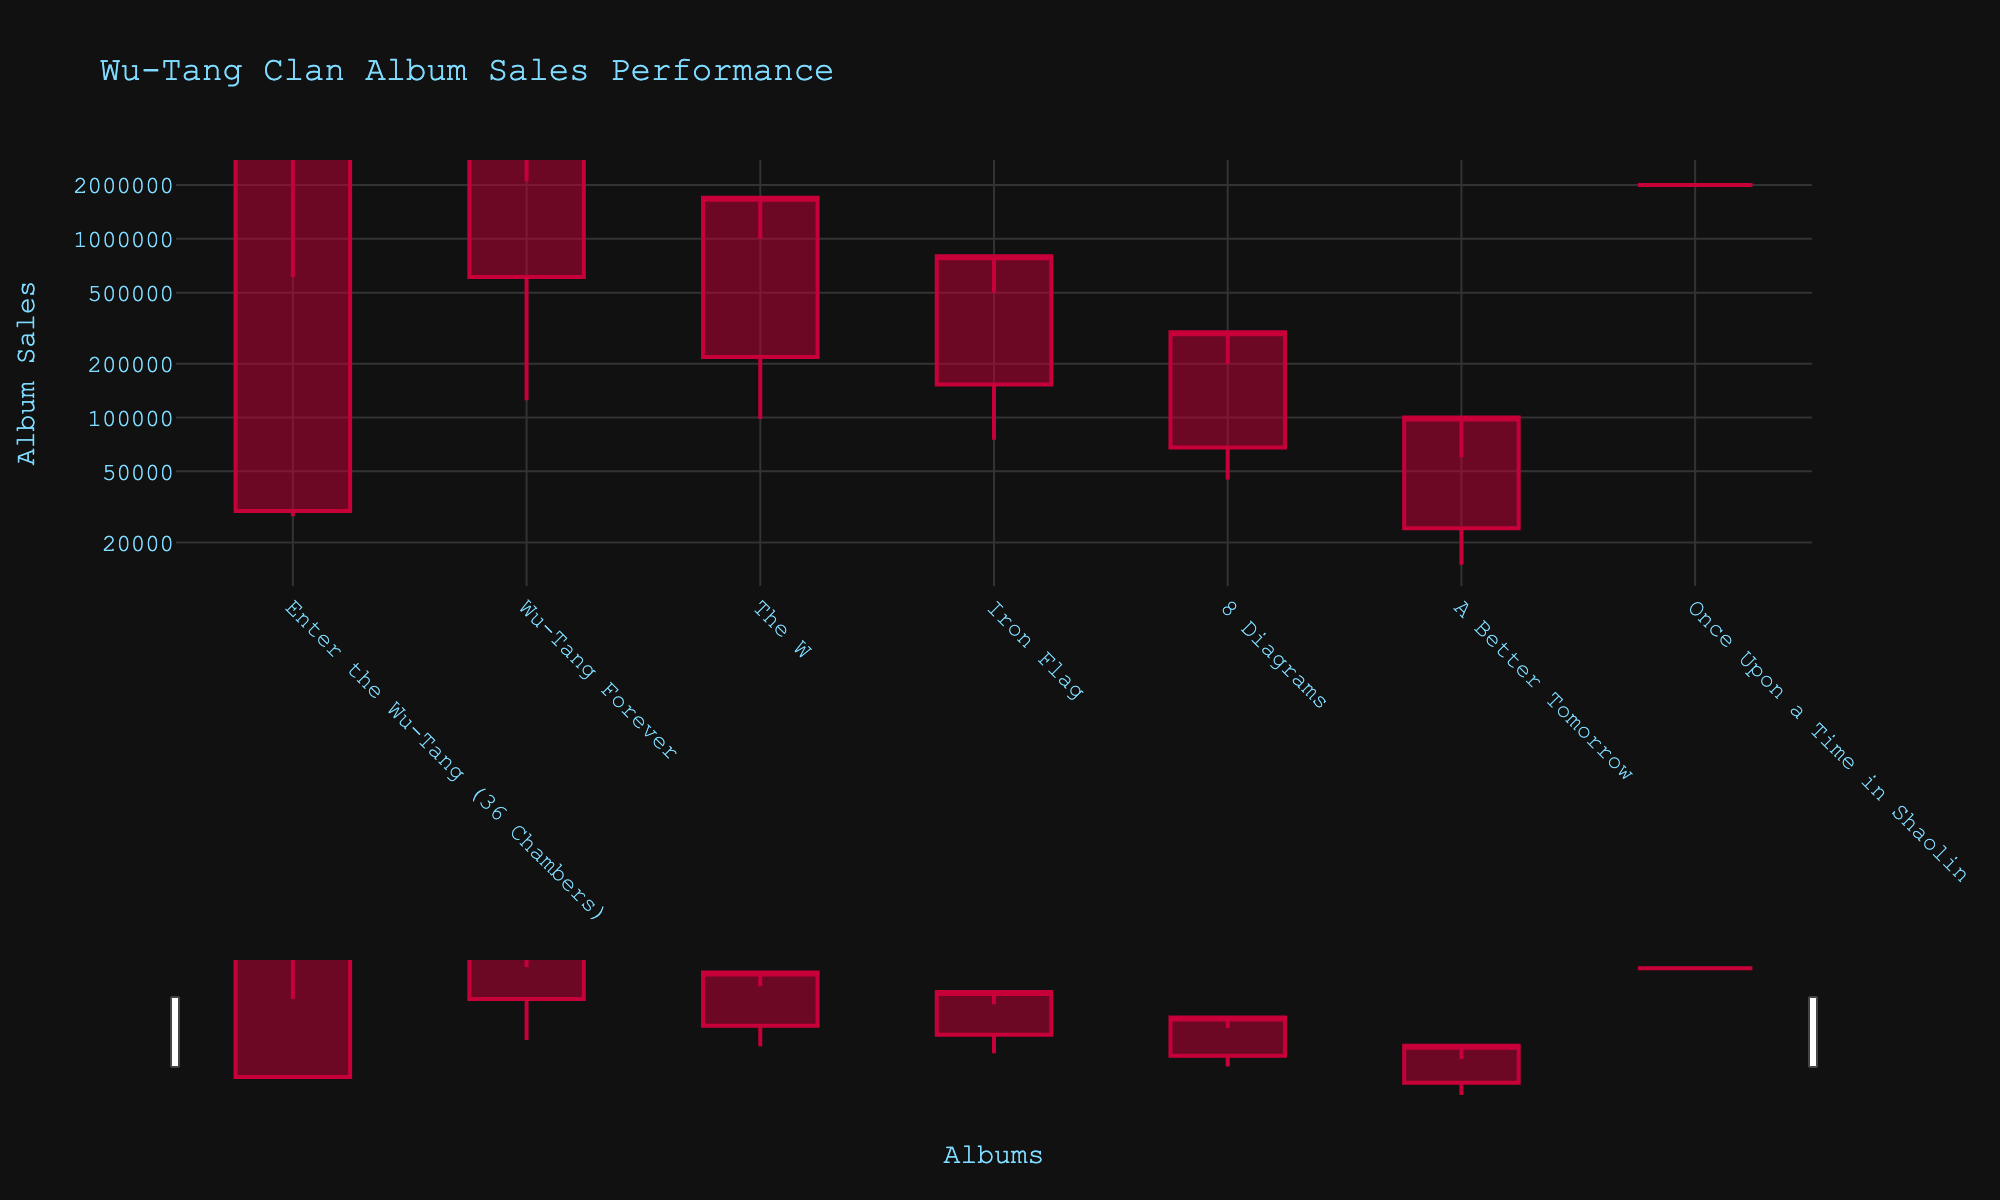what is the title of the chart? The title is typically displayed at the top center of the figure and shows the purpose of the plot. In this chart, the title is "Wu-Tang Clan Album Sales Performance".
Answer: Wu-Tang Clan Album Sales Performance how many initial album sales are displayed in the chart? Count the number of individual bars (or data points) in the figure to determine how many initial album sales are represented. Each bar corresponds to one album's sales performance.
Answer: 7 Which album had the highest opening week sales? Look at the opening week values for each album and identify the one with the largest value. The opening week sales are represented by the bottom of the colored bar when it starts.
Answer: Wu-Tang Forever What is the lowest recorded sales peak among all the albums? Identify and compare the highest peak values for each album and find the smallest one by observing the top of the bars.
Answer: 60,000 (A Better Tomorrow) which album shows the least difference between its highest peak and lowest dip? Subtract the lowest dip from the highest peak for each album, then identify the album with the smallest difference. "Once Upon a Time in Shaolin" has the same value for highest peak and lowest dip resulting in the smallest difference (0).
Answer: Once Upon a Time in Shaolin Which album had sales performance close to 1 million at its peak? Look for the album whose highest peak value is nearest to 1 million. The highest peak is represented by the highest point of the bars.
Answer: The W What is the average opening week sales for all albums? To calculate the average, sum the opening week sales of all the albums and then divide the total by the number of albums. The opening week sales figures to sum are 30,000, 612,000, 218,000, 153,000, 68,000, 24,000, and 2,000,000. Adding these gives 3,105,000, and dividing by 7 gives the average.
Answer: 443,571 Which album maintained the highest closing figures in the chart? Look at the closing figures for each album and identify the one with the highest value. The closing figures are depicted by the top of the bar for each album.
Answer: Wu-Tang Forever Compare the sales dip between 'The W' and 'Iron Flag'. Which experienced a smaller drop? Find the difference between the highest peak and lowest dip for both albums. For 'The W', the drop is 1,000,000 - 98,000 = 902,000. For 'Iron Flag', the drop is 500,000 - 75,000 = 425,000. 'Iron Flag' experienced a smaller drop.
Answer: Iron Flag Based on the chart, which album had a closing figure notable for being exactly the same as its opening week sales? Check if there is any album where the opening week sales value is equal to the closing figures. For 'Once Upon a Time in Shaolin', both numbers are 2,000,000.
Answer: Once Upon a Time in Shaolin 